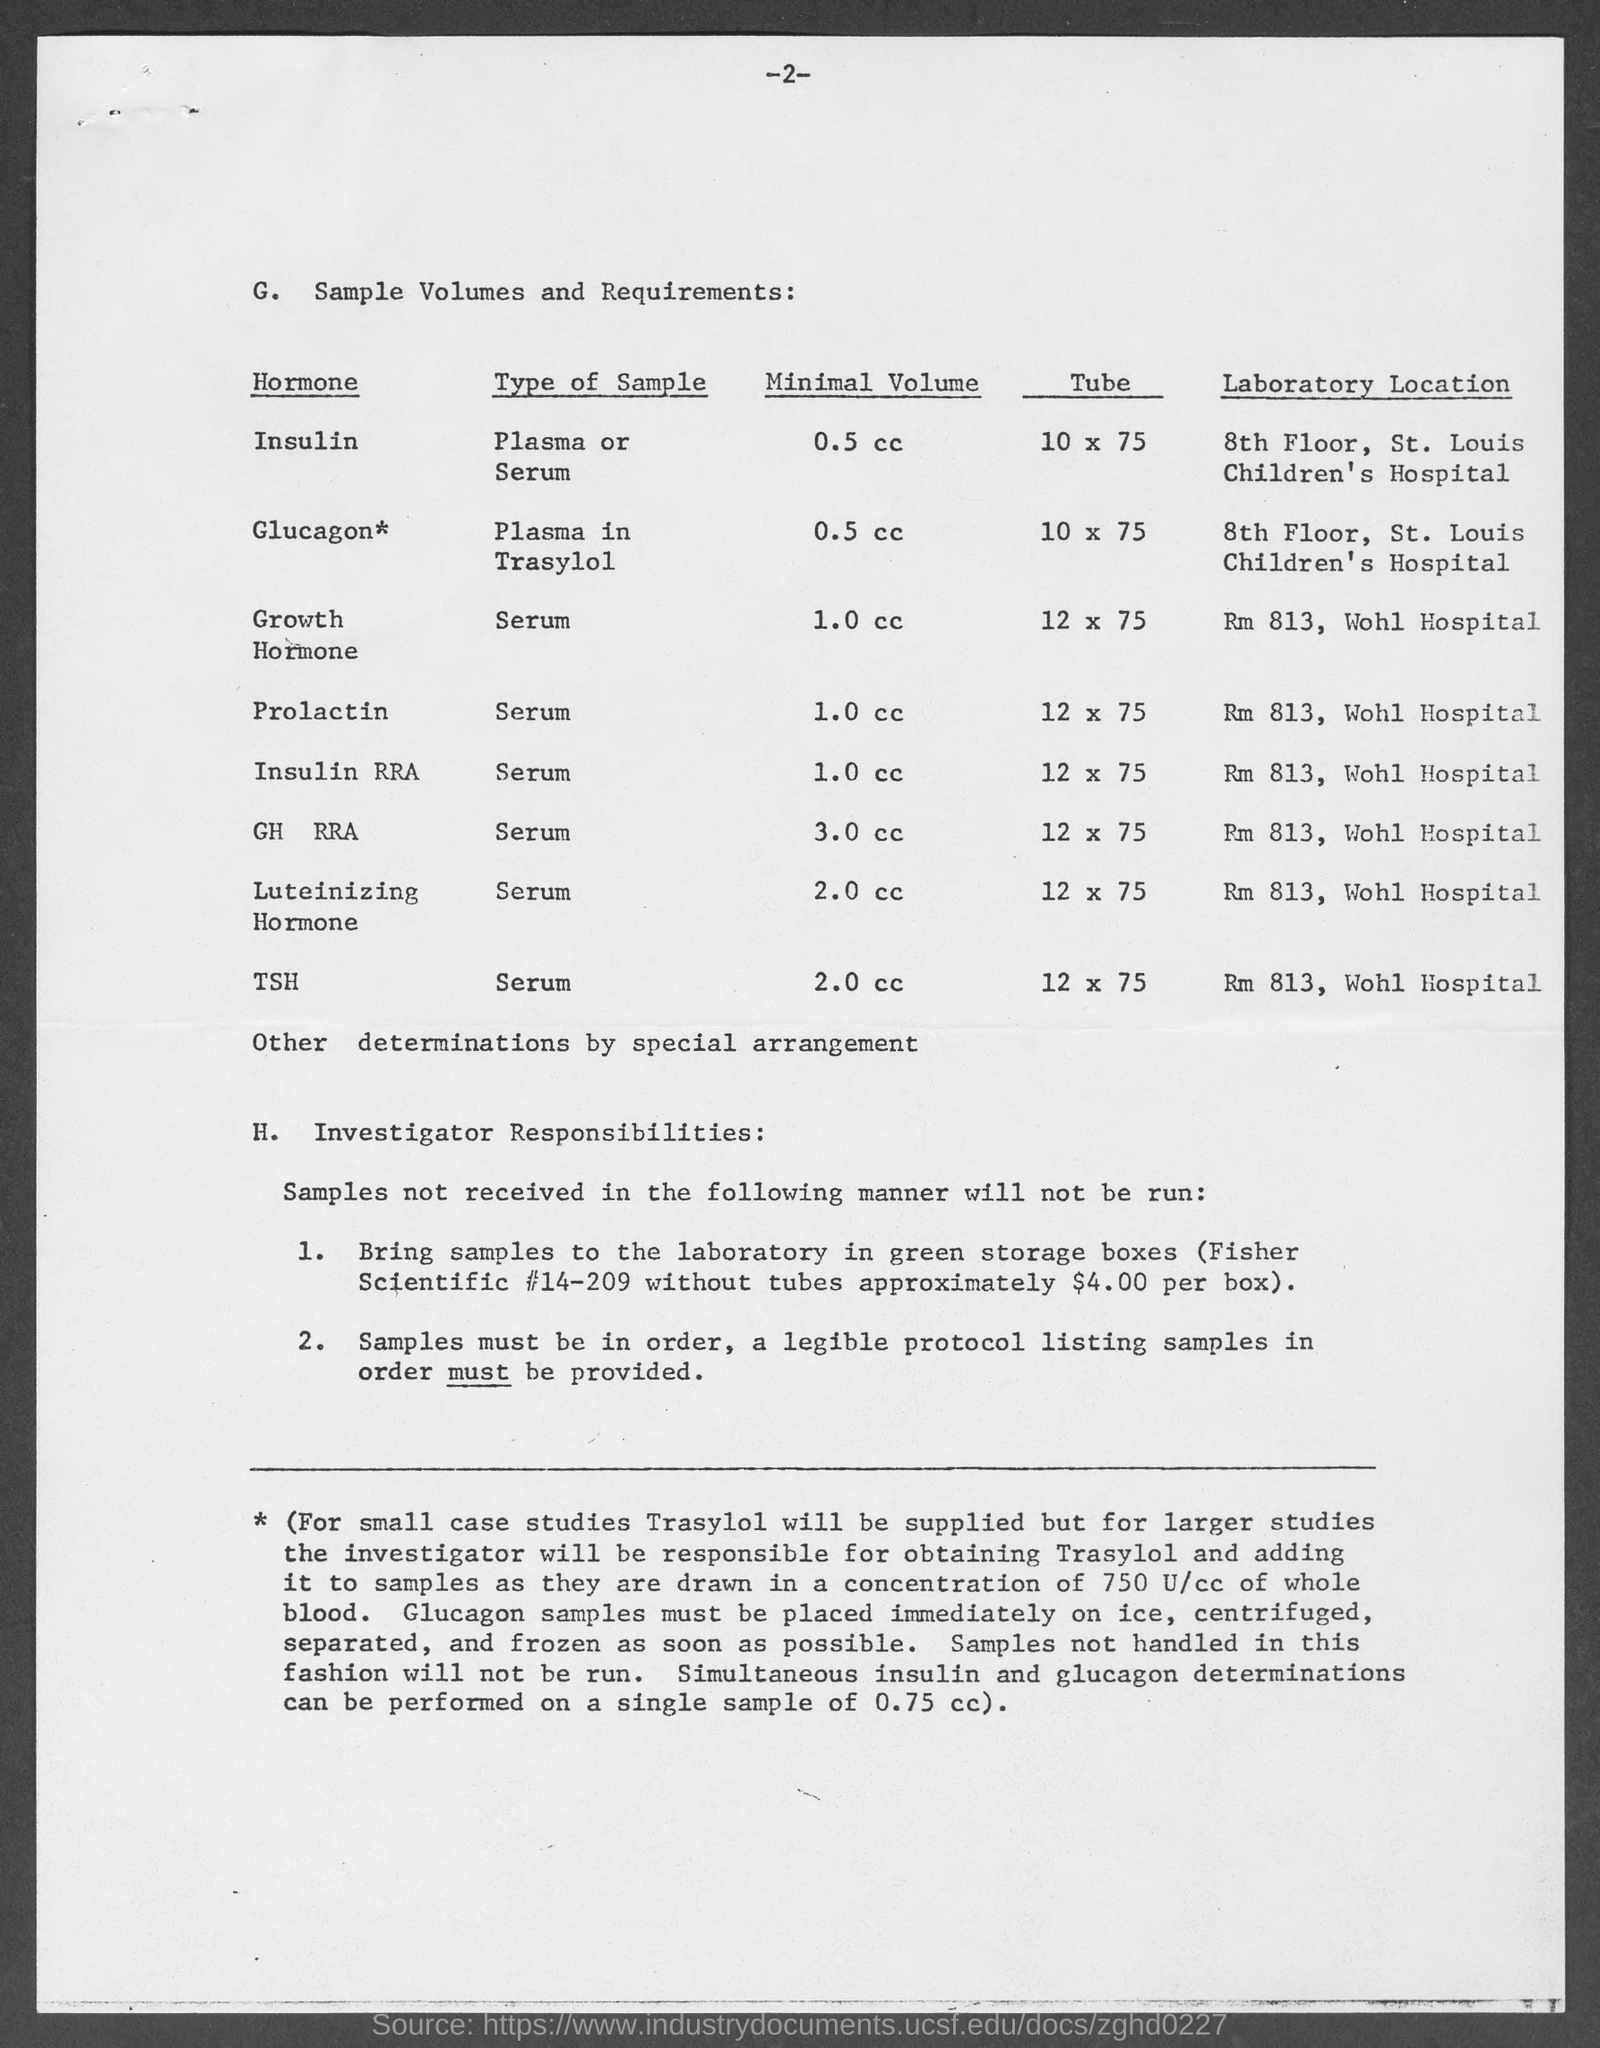Specify some key components in this picture. The minimal volume of insulin required is 0.5 cc. The minimum volume for a GH-RRA injection is 3.0 cc. The minimum volume of Glucagon is 0.5 cc. The minimal volume of Prolactin is 1.0 cc. The type of sample used for an Insulin RRA is serum. 